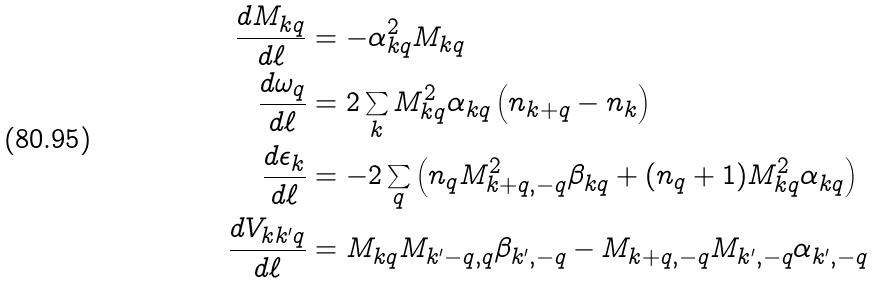<formula> <loc_0><loc_0><loc_500><loc_500>\frac { d M _ { k q } } { d \ell } & = - \alpha _ { k q } ^ { 2 } M _ { k q } \\ \frac { d \omega _ { q } } { d \ell } & = 2 \sum _ { k } M _ { k q } ^ { 2 } \alpha _ { k q } \left ( n _ { k + q } - n _ { k } \right ) \\ \frac { d \epsilon _ { k } } { d \ell } & = - 2 \sum _ { q } \left ( n _ { q } M _ { k + q , - q } ^ { 2 } \beta _ { k q } + ( n _ { q } + 1 ) M _ { k q } ^ { 2 } \alpha _ { k q } \right ) \\ \frac { d V _ { k k ^ { \prime } q } } { d \ell } & = M _ { k q } M _ { k ^ { \prime } - q , q } \beta _ { k ^ { \prime } , - q } - M _ { k + q , - q } M _ { k ^ { \prime } , - q } \alpha _ { k ^ { \prime } , - q }</formula> 